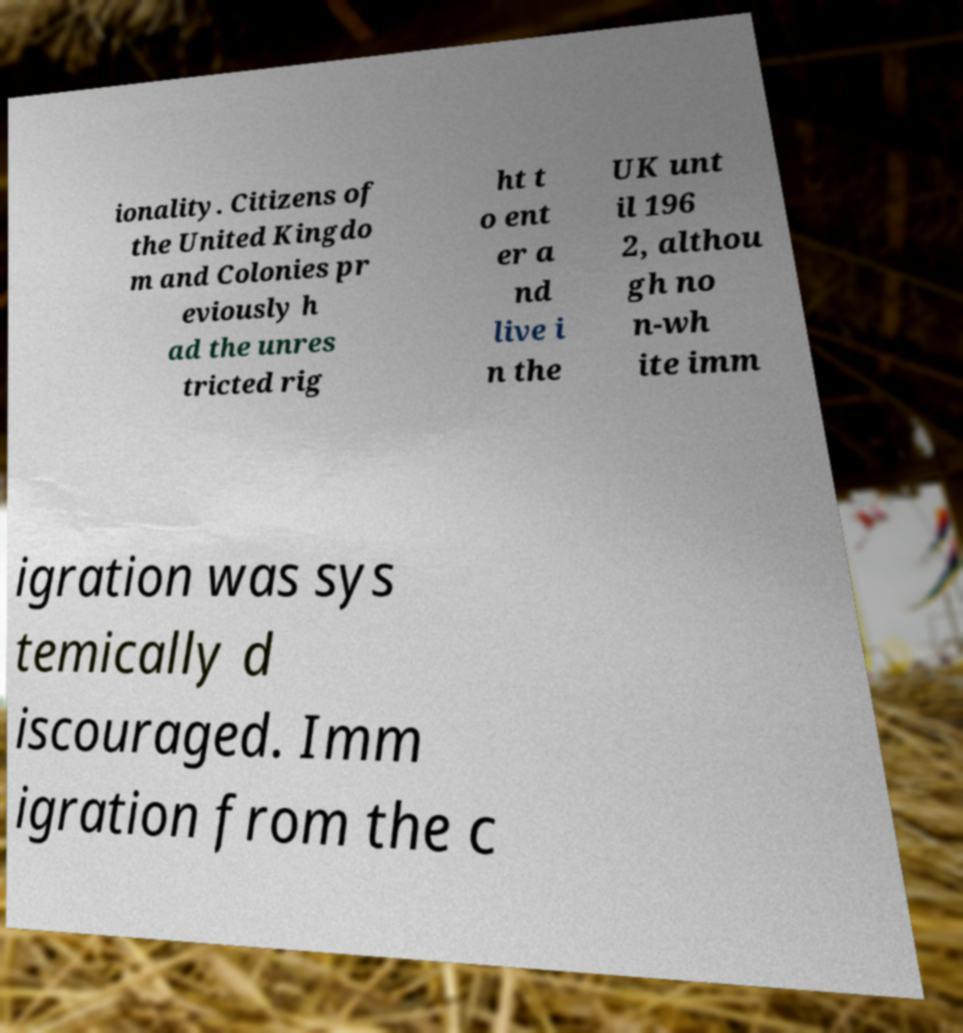Please identify and transcribe the text found in this image. ionality. Citizens of the United Kingdo m and Colonies pr eviously h ad the unres tricted rig ht t o ent er a nd live i n the UK unt il 196 2, althou gh no n-wh ite imm igration was sys temically d iscouraged. Imm igration from the c 